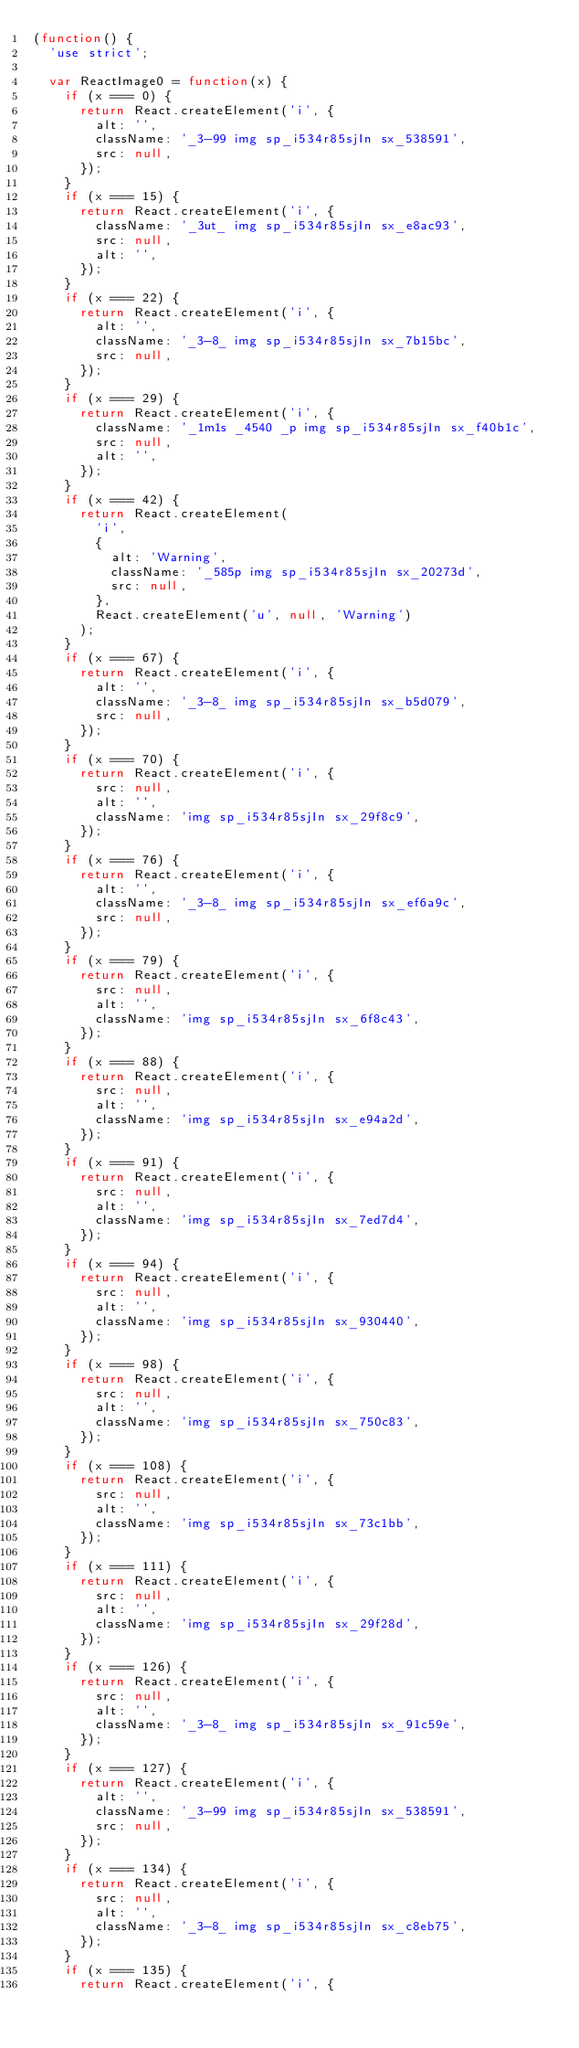Convert code to text. <code><loc_0><loc_0><loc_500><loc_500><_JavaScript_>(function() {
  'use strict';

  var ReactImage0 = function(x) {
    if (x === 0) {
      return React.createElement('i', {
        alt: '',
        className: '_3-99 img sp_i534r85sjIn sx_538591',
        src: null,
      });
    }
    if (x === 15) {
      return React.createElement('i', {
        className: '_3ut_ img sp_i534r85sjIn sx_e8ac93',
        src: null,
        alt: '',
      });
    }
    if (x === 22) {
      return React.createElement('i', {
        alt: '',
        className: '_3-8_ img sp_i534r85sjIn sx_7b15bc',
        src: null,
      });
    }
    if (x === 29) {
      return React.createElement('i', {
        className: '_1m1s _4540 _p img sp_i534r85sjIn sx_f40b1c',
        src: null,
        alt: '',
      });
    }
    if (x === 42) {
      return React.createElement(
        'i',
        {
          alt: 'Warning',
          className: '_585p img sp_i534r85sjIn sx_20273d',
          src: null,
        },
        React.createElement('u', null, 'Warning')
      );
    }
    if (x === 67) {
      return React.createElement('i', {
        alt: '',
        className: '_3-8_ img sp_i534r85sjIn sx_b5d079',
        src: null,
      });
    }
    if (x === 70) {
      return React.createElement('i', {
        src: null,
        alt: '',
        className: 'img sp_i534r85sjIn sx_29f8c9',
      });
    }
    if (x === 76) {
      return React.createElement('i', {
        alt: '',
        className: '_3-8_ img sp_i534r85sjIn sx_ef6a9c',
        src: null,
      });
    }
    if (x === 79) {
      return React.createElement('i', {
        src: null,
        alt: '',
        className: 'img sp_i534r85sjIn sx_6f8c43',
      });
    }
    if (x === 88) {
      return React.createElement('i', {
        src: null,
        alt: '',
        className: 'img sp_i534r85sjIn sx_e94a2d',
      });
    }
    if (x === 91) {
      return React.createElement('i', {
        src: null,
        alt: '',
        className: 'img sp_i534r85sjIn sx_7ed7d4',
      });
    }
    if (x === 94) {
      return React.createElement('i', {
        src: null,
        alt: '',
        className: 'img sp_i534r85sjIn sx_930440',
      });
    }
    if (x === 98) {
      return React.createElement('i', {
        src: null,
        alt: '',
        className: 'img sp_i534r85sjIn sx_750c83',
      });
    }
    if (x === 108) {
      return React.createElement('i', {
        src: null,
        alt: '',
        className: 'img sp_i534r85sjIn sx_73c1bb',
      });
    }
    if (x === 111) {
      return React.createElement('i', {
        src: null,
        alt: '',
        className: 'img sp_i534r85sjIn sx_29f28d',
      });
    }
    if (x === 126) {
      return React.createElement('i', {
        src: null,
        alt: '',
        className: '_3-8_ img sp_i534r85sjIn sx_91c59e',
      });
    }
    if (x === 127) {
      return React.createElement('i', {
        alt: '',
        className: '_3-99 img sp_i534r85sjIn sx_538591',
        src: null,
      });
    }
    if (x === 134) {
      return React.createElement('i', {
        src: null,
        alt: '',
        className: '_3-8_ img sp_i534r85sjIn sx_c8eb75',
      });
    }
    if (x === 135) {
      return React.createElement('i', {</code> 